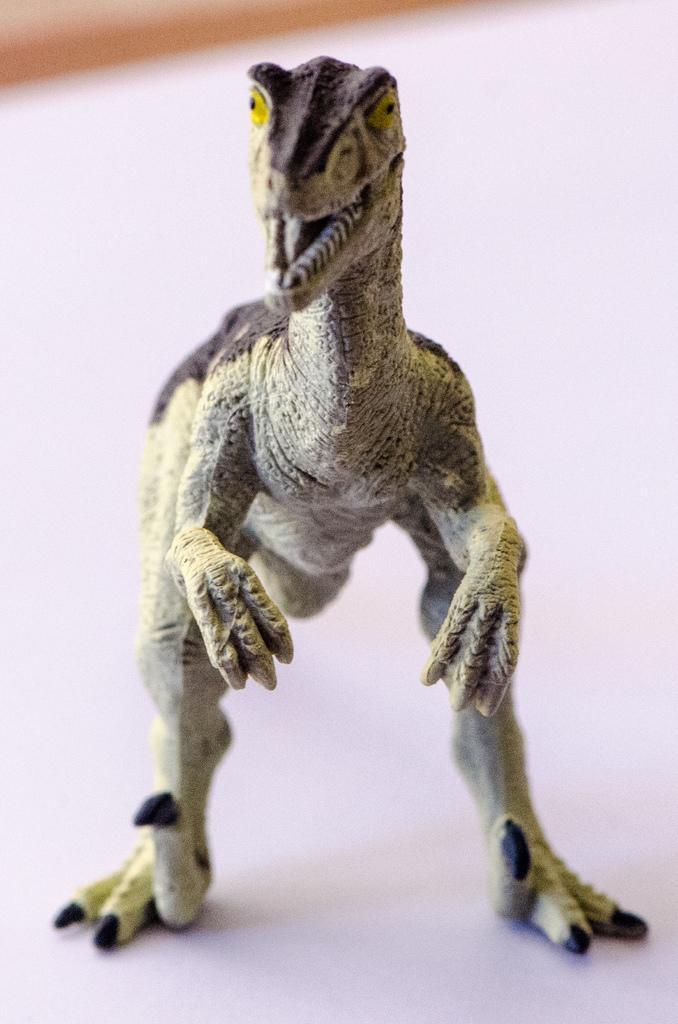How would you summarize this image in a sentence or two? In this image we can see a dragon toy. 